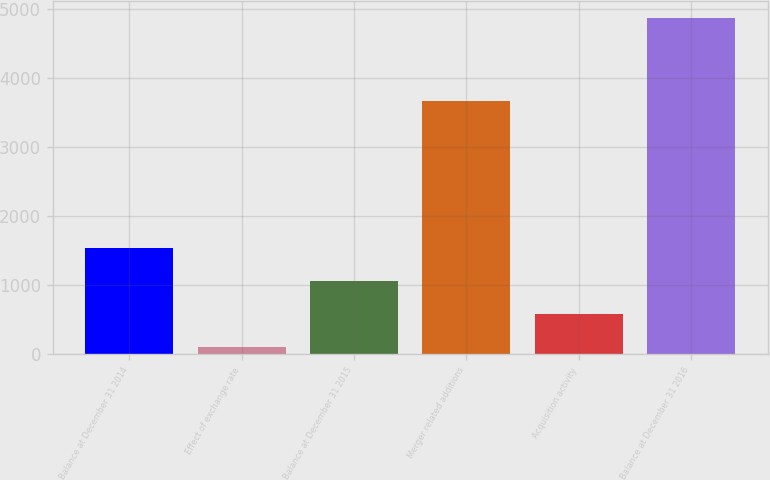Convert chart. <chart><loc_0><loc_0><loc_500><loc_500><bar_chart><fcel>Balance at December 31 2014<fcel>Effect of exchange rate<fcel>Balance at December 31 2015<fcel>Merger related additions<fcel>Acquisition activity<fcel>Balance at December 31 2016<nl><fcel>1532.72<fcel>106.4<fcel>1057.28<fcel>3663.5<fcel>581.84<fcel>4860.8<nl></chart> 